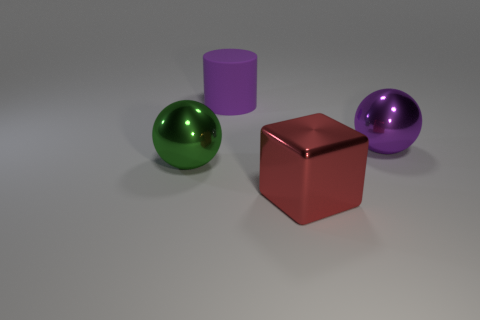There is a big sphere that is the same color as the cylinder; what material is it?
Give a very brief answer. Metal. Are there any other things that have the same material as the purple cylinder?
Give a very brief answer. No. There is a red thing that is made of the same material as the big purple ball; what is its size?
Offer a terse response. Large. What material is the large thing that is both in front of the purple rubber cylinder and on the left side of the red thing?
Your answer should be compact. Metal. What number of red metal things are the same size as the purple metallic ball?
Your answer should be compact. 1. What is the material of the other thing that is the same shape as the green shiny thing?
Your answer should be compact. Metal. What number of things are big cubes in front of the green metal ball or big purple things that are right of the rubber cylinder?
Give a very brief answer. 2. Do the big red metal object and the object that is right of the metallic block have the same shape?
Offer a very short reply. No. The metallic object that is behind the object that is to the left of the big purple thing that is to the left of the metal block is what shape?
Your response must be concise. Sphere. What number of other things are there of the same material as the purple sphere
Ensure brevity in your answer.  2. 